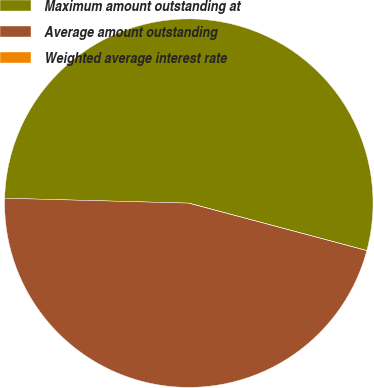<chart> <loc_0><loc_0><loc_500><loc_500><pie_chart><fcel>Maximum amount outstanding at<fcel>Average amount outstanding<fcel>Weighted average interest rate<nl><fcel>53.72%<fcel>46.28%<fcel>0.0%<nl></chart> 